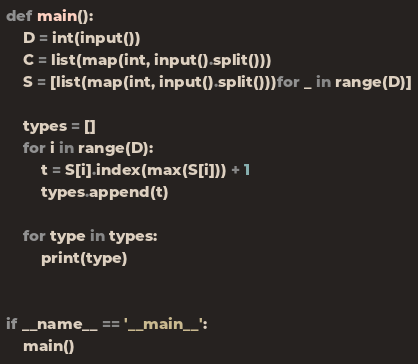Convert code to text. <code><loc_0><loc_0><loc_500><loc_500><_Python_>def main():
    D = int(input())
    C = list(map(int, input().split()))
    S = [list(map(int, input().split()))for _ in range(D)]

    types = []
    for i in range(D):
        t = S[i].index(max(S[i])) + 1
        types.append(t)

    for type in types:
        print(type)


if __name__ == '__main__':
    main()
</code> 